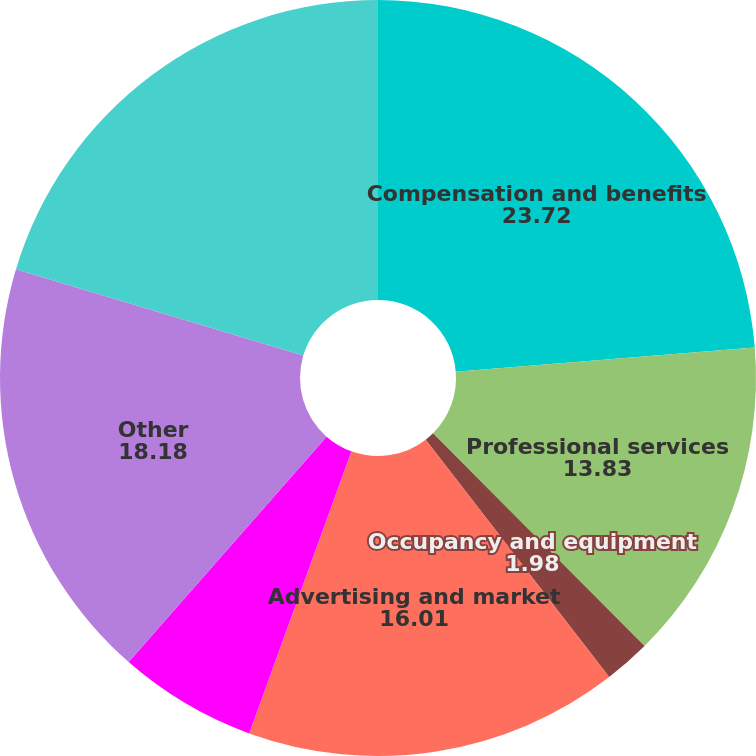Convert chart to OTSL. <chart><loc_0><loc_0><loc_500><loc_500><pie_chart><fcel>Compensation and benefits<fcel>Professional services<fcel>Occupancy and equipment<fcel>Advertising and market<fcel>Depreciation and amortization<fcel>Other<fcel>Total expenses excluding<nl><fcel>23.72%<fcel>13.83%<fcel>1.98%<fcel>16.01%<fcel>5.93%<fcel>18.18%<fcel>20.36%<nl></chart> 